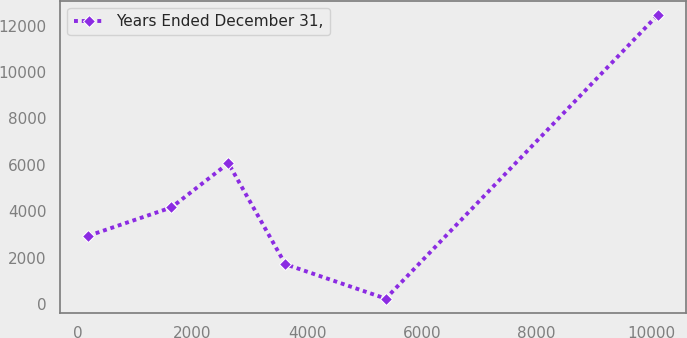Convert chart to OTSL. <chart><loc_0><loc_0><loc_500><loc_500><line_chart><ecel><fcel>Years Ended December 31,<nl><fcel>182.57<fcel>2941.9<nl><fcel>1632.48<fcel>4165.6<nl><fcel>2626.36<fcel>6070.03<nl><fcel>3620.24<fcel>1718.2<nl><fcel>5371.85<fcel>234.64<nl><fcel>10121.3<fcel>12471.6<nl></chart> 